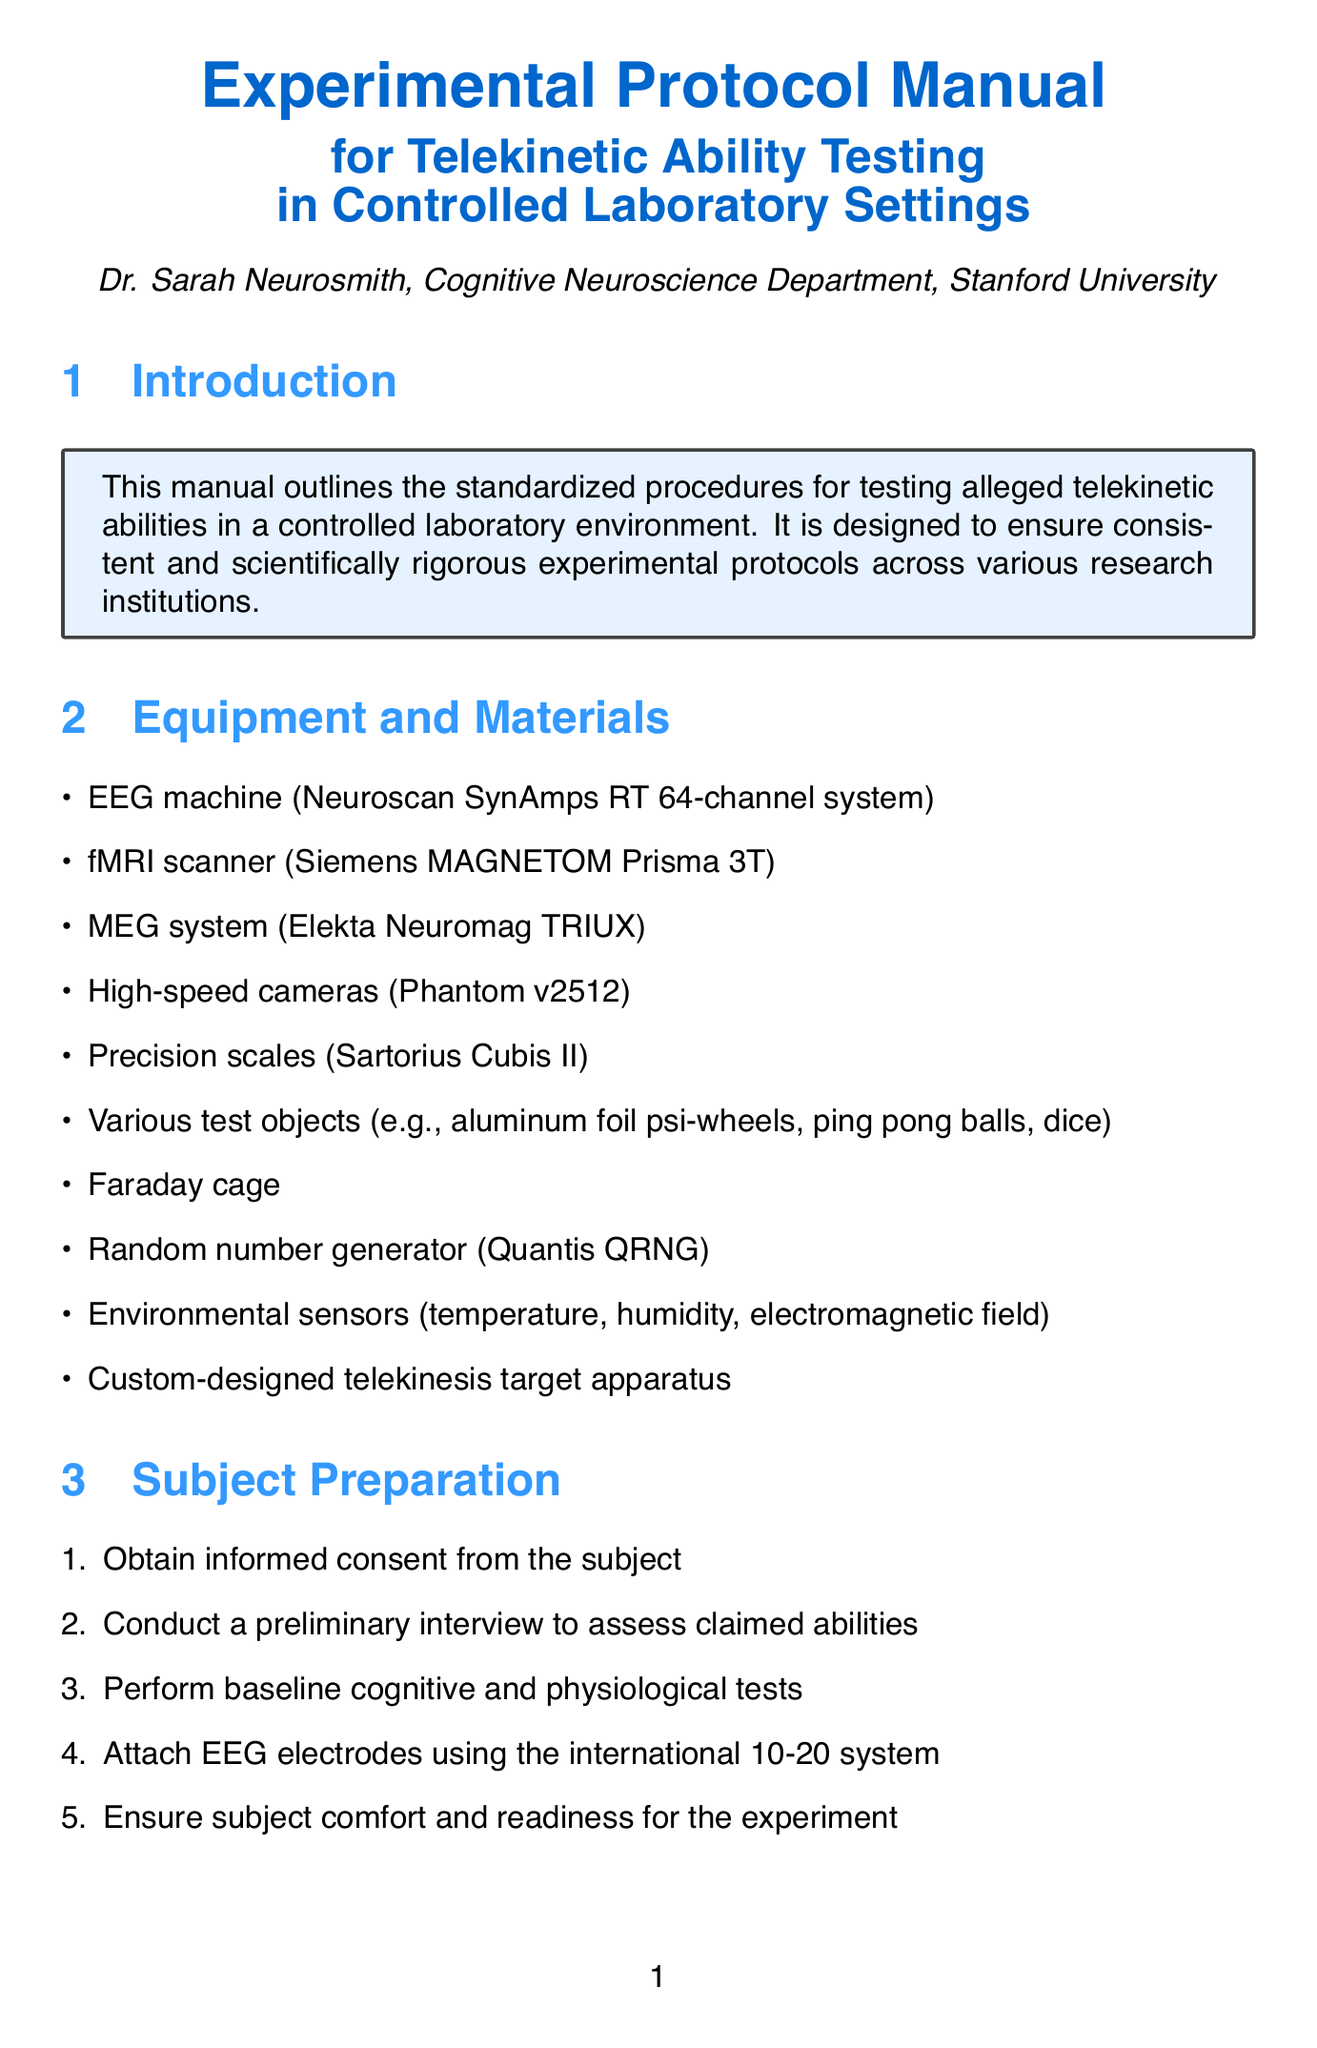What is the title of the manual? The title of the manual is explicitly stated at the beginning of the document.
Answer: Experimental Protocol Manual for Telekinetic Ability Testing in Controlled Laboratory Settings Who is the author of the manual? The author is mentioned in the introduction section of the document.
Answer: Dr. Sarah Neurosmith What equipment is specifically mentioned for EEG recording? The manual lists specific equipment in the Equipment and Materials section.
Answer: Neuroscan SynAmps RT 64-channel system How long is the Baseline Recording phase? The duration of the Baseline Recording is provided in the Testing Protocol section.
Answer: 10 minutes What are the safety guidelines related to MRI screening? The safety considerations are listed in a dedicated section with specific guidelines.
Answer: Ensure proper screening for MRI contraindications How many phases are there in the Testing Protocol? The Testing Protocol section outlines multiple phases, and their count can be determined from the description.
Answer: Four What should be documented according to the Reporting and Documentation section? The requirements for documentation are specified within the Reporting and Documentation section.
Answer: Maintain detailed logs of all experimental procedures What is a potential ethical consideration mentioned in the document? Ethical considerations are outlined in their respective section, highlighting specific points.
Answer: Protect subject privacy and confidentiality What type of sensors are mentioned in the Equipment and Materials section? The manual details the types of equipment and materials needed for the experiments.
Answer: Environmental sensors 